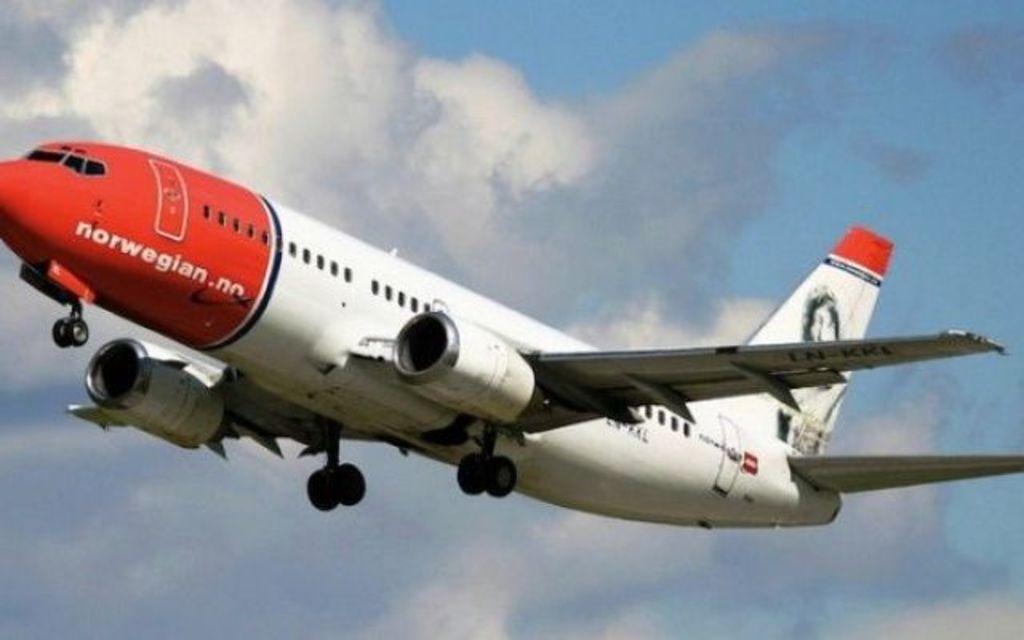Who owns this plane?
Offer a very short reply. Norwegian. What website is shown on this plane?
Give a very brief answer. Norwegian.no. 